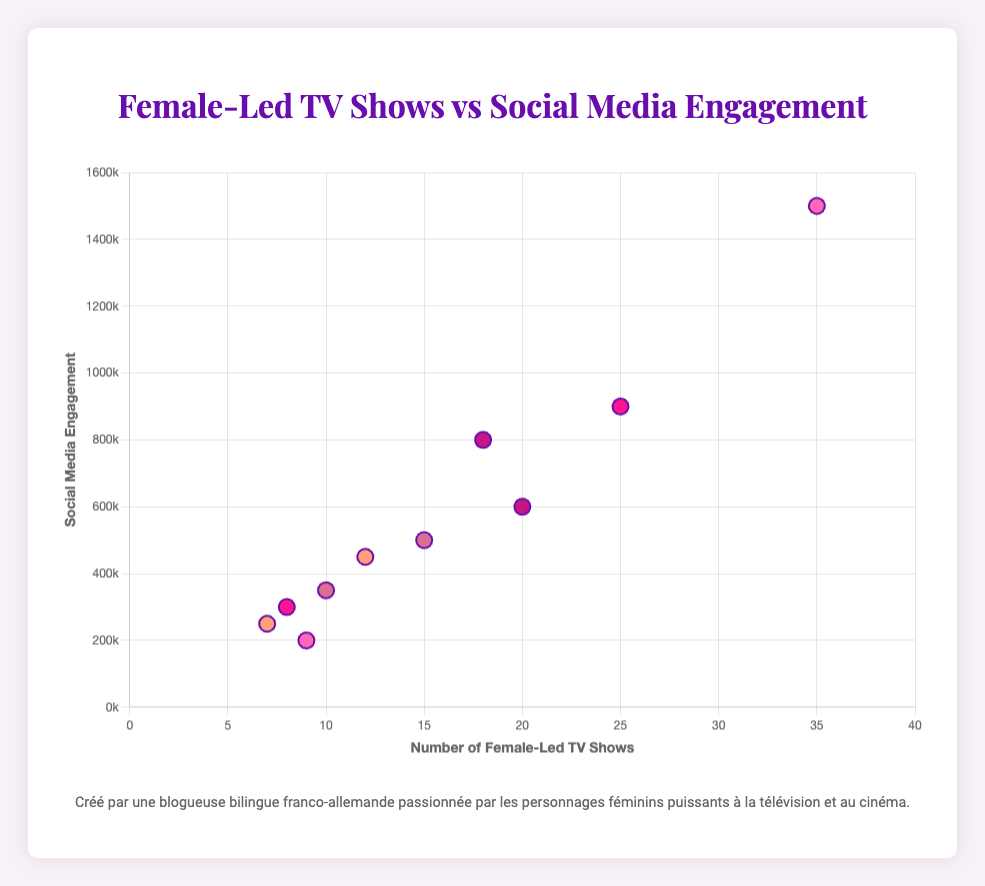What's the title of the scatter plot? The title of a scatter plot is typically displayed at the top of the chart. In this case, the title is "Female-Led TV Shows vs Social Media Engagement" as indicated in the HTML structure of the code.
Answer: Female-Led TV Shows vs Social Media Engagement What does the x-axis represent? The x-axis on the scatter plot is labeled with "Number of Female-Led TV Shows." This can be inferred from examining the axis title within the data configuration.
Answer: Number of Female-Led TV Shows Which country has the highest social media engagement? By looking at the scatter plot, identify the point with the maximum y-value. The U.S. has the highest social media engagement with 1,500,000 engagements.
Answer: USA How many female-led TV shows are there in Germany? Locate the data point representing Germany on the scatter plot. According to the given data, Germany has 10 female-led TV shows.
Answer: 10 Which country has the lowest number of female-led TV shows? Determine the data point with the smallest x-value. In this case, Spain has the lowest number of female-led TV shows, which is 7.
Answer: Spain What is the social media engagement for France? Refer to France's data point on the scatter plot. The social media engagement for France is 300,000.
Answer: 300,000 Which country has more social media engagement: Japan or Australia? Compare the y-values (social media engagement) of the points representing Japan and Australia. Japan has 500,000 engagements, while Australia has 200,000. Thus, Japan has more social media engagement.
Answer: Japan Which country has more female-led TV shows: UK or South Korea? Compare the x-values (number of female-led TV shows) of the points representing UK and South Korea. The UK has 18 shows, while South Korea has 20. Hence, South Korea has more female-led TV shows.
Answer: South Korea What is the total number of female-led TV shows from France, Germany, and Spain? Add the number of female-led TV shows for France (8), Germany (10), and Spain (7). The total is 8 + 10 + 7 = 25.
Answer: 25 What is the average social media engagement of countries with more than 20 female-led TV shows? Identify countries with more than 20 female-led TV shows: USA (35 shows, 1,500,000 engagements) and India (25 shows, 900,000 engagements). Calculate the average engagement: (1,500,000 + 900,000) / 2 = 1,200,000.
Answer: 1,200,000 